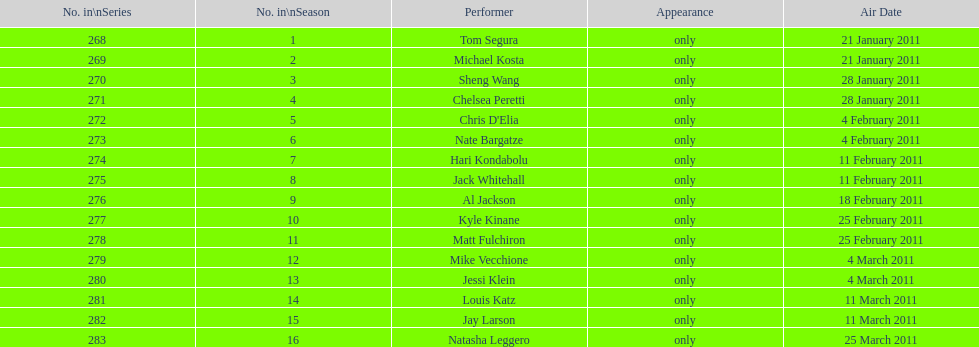How many performers appeared on the air date 21 january 2011? 2. 